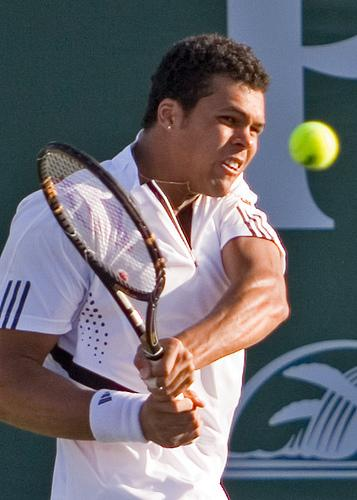This playing is making what shot? backhand 